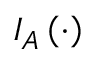<formula> <loc_0><loc_0><loc_500><loc_500>I _ { A } \left ( \cdot \right )</formula> 